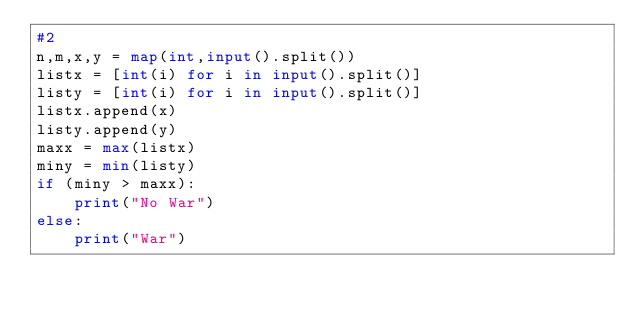<code> <loc_0><loc_0><loc_500><loc_500><_Python_>#2
n,m,x,y = map(int,input().split())
listx = [int(i) for i in input().split()]
listy = [int(i) for i in input().split()]
listx.append(x)
listy.append(y)
maxx = max(listx)
miny = min(listy)
if (miny > maxx):
    print("No War")
else:
    print("War")</code> 